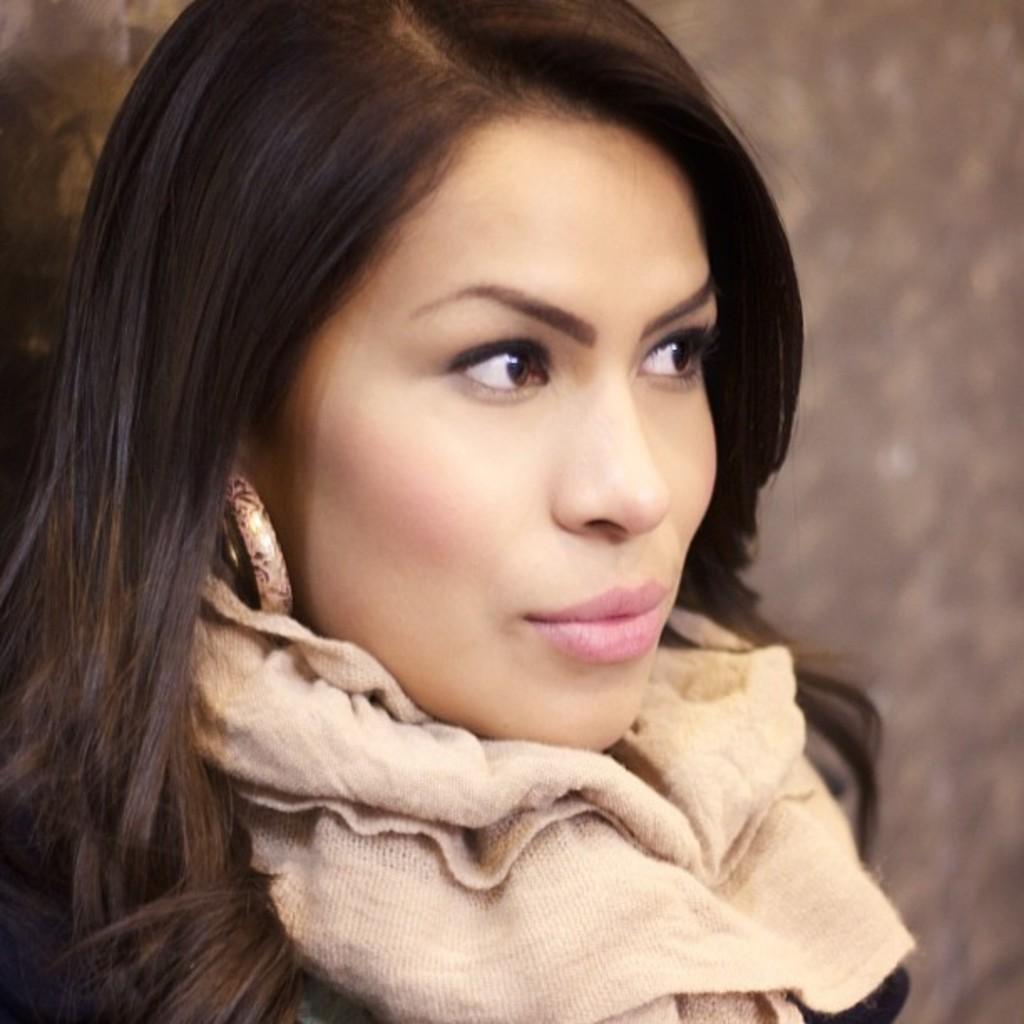Who is present in the image? There is a woman in the image. What can be seen in the background of the image? There is a wall in the background of the image. What accessory is the woman wearing? The woman is wearing a scarf. What type of bubble can be seen floating near the woman in the image? There is no bubble present in the image. 